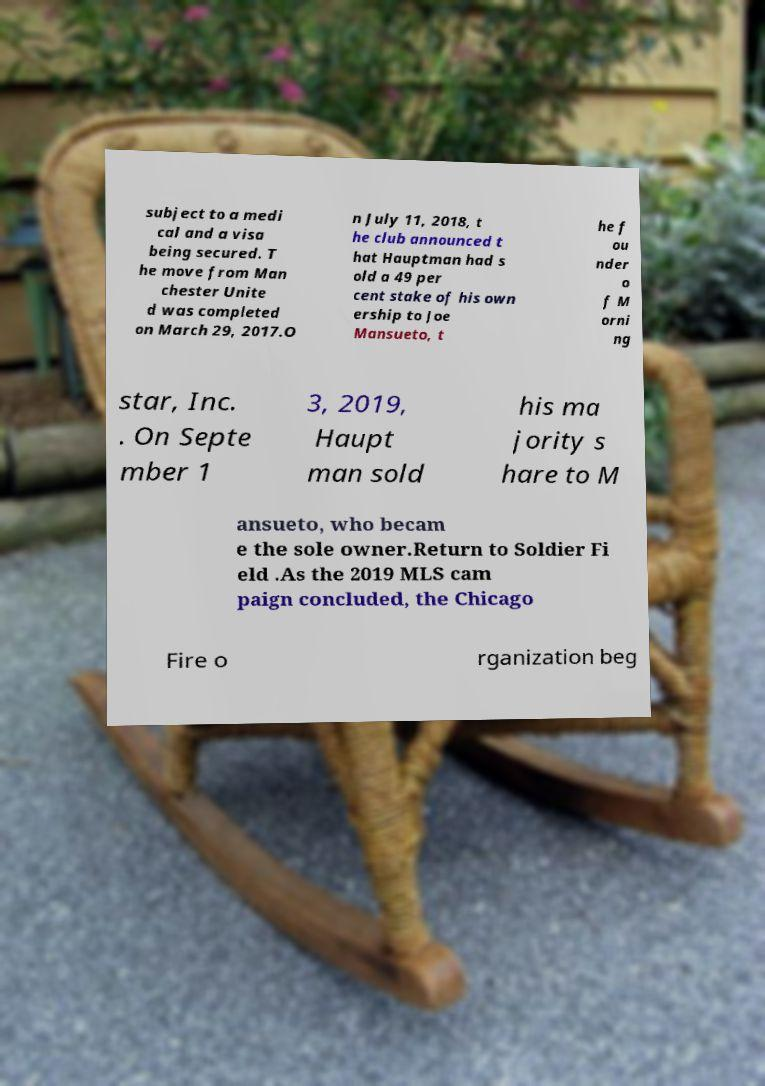Please read and relay the text visible in this image. What does it say? subject to a medi cal and a visa being secured. T he move from Man chester Unite d was completed on March 29, 2017.O n July 11, 2018, t he club announced t hat Hauptman had s old a 49 per cent stake of his own ership to Joe Mansueto, t he f ou nder o f M orni ng star, Inc. . On Septe mber 1 3, 2019, Haupt man sold his ma jority s hare to M ansueto, who becam e the sole owner.Return to Soldier Fi eld .As the 2019 MLS cam paign concluded, the Chicago Fire o rganization beg 